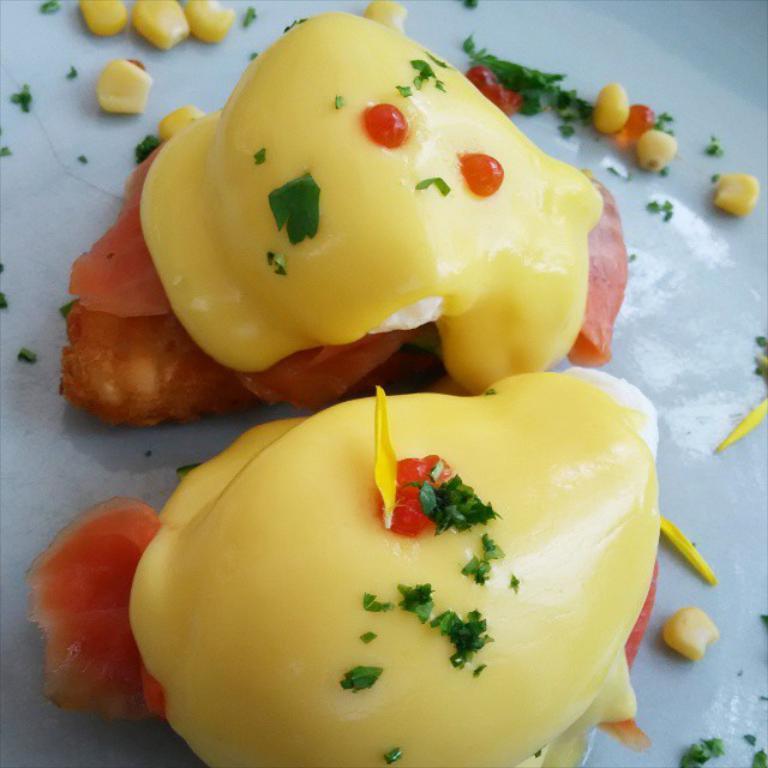In one or two sentences, can you explain what this image depicts? In the foreground of this image, it looks like a dessert item on a white surface. 